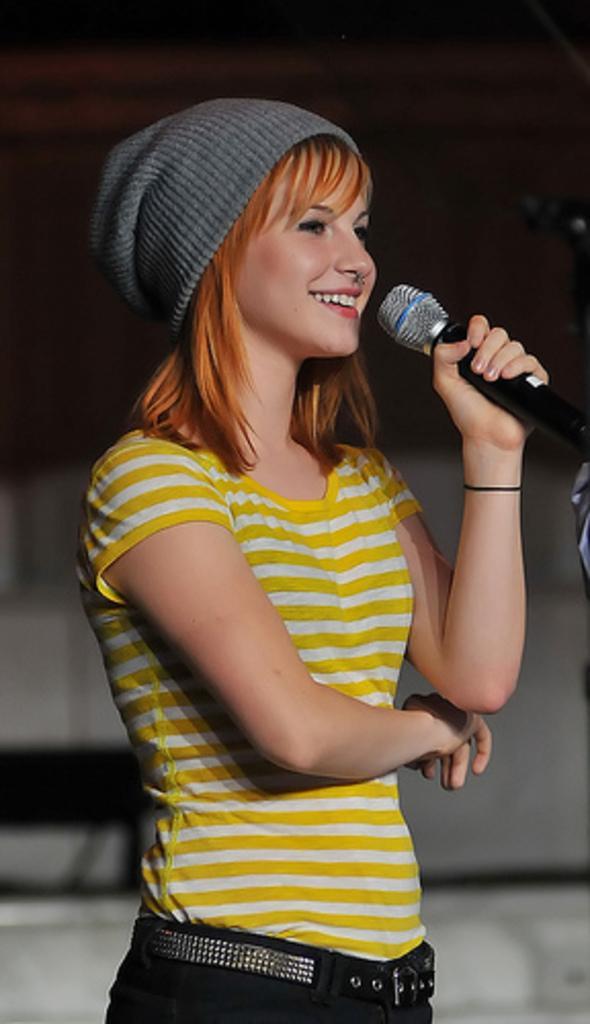How would you summarize this image in a sentence or two? In this image there is a woman standing and smiling by holding a microphone in her hand , and there is a dark back ground. 